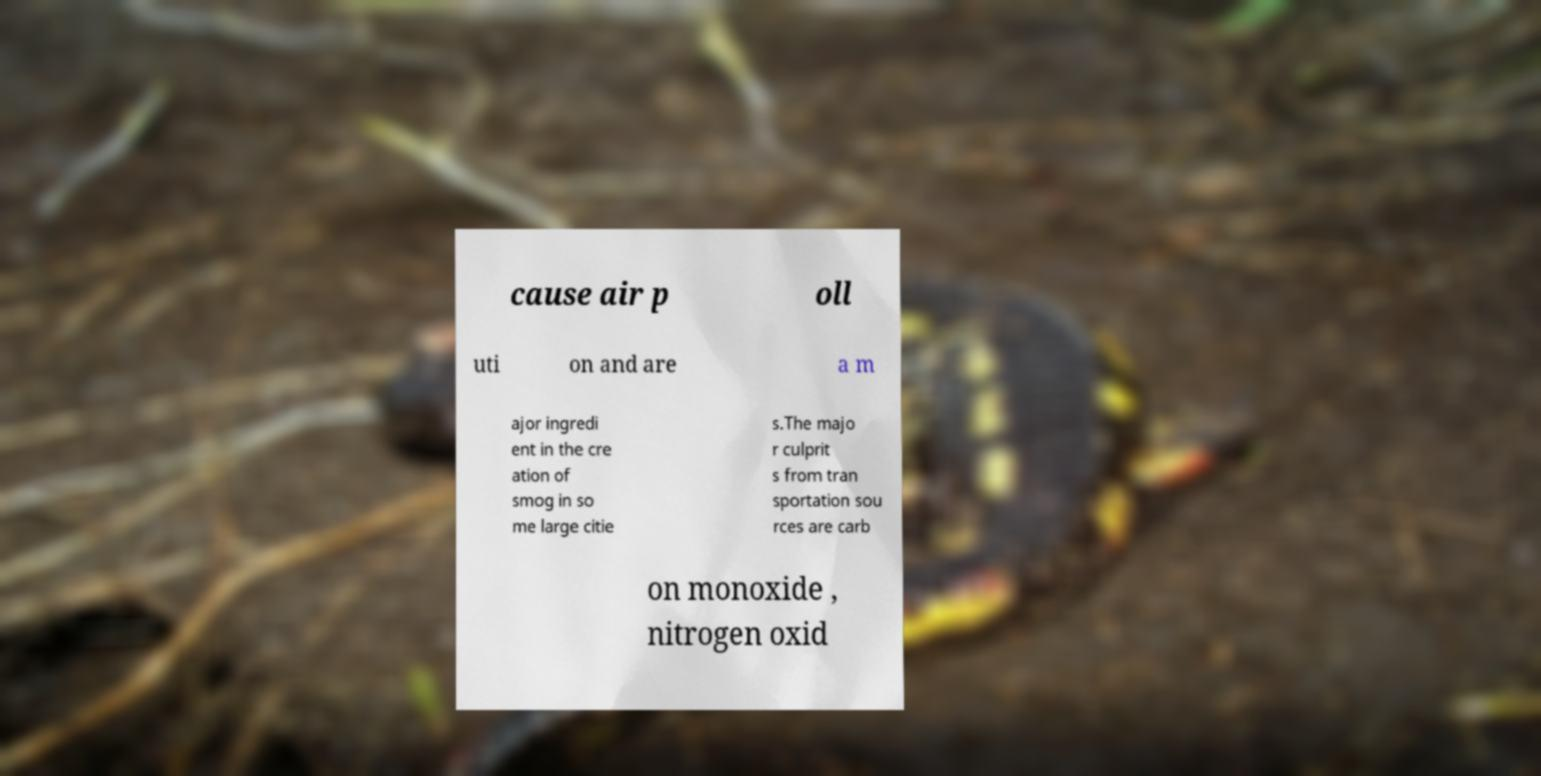What messages or text are displayed in this image? I need them in a readable, typed format. cause air p oll uti on and are a m ajor ingredi ent in the cre ation of smog in so me large citie s.The majo r culprit s from tran sportation sou rces are carb on monoxide , nitrogen oxid 